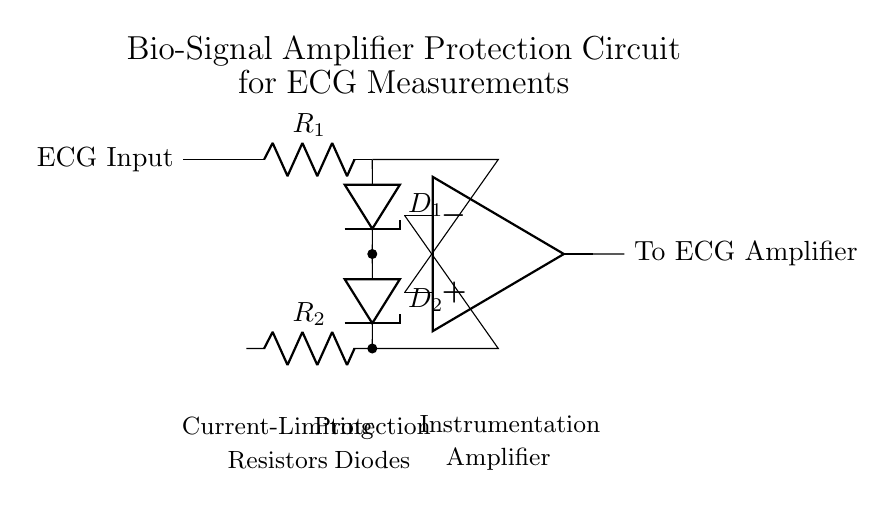What is the purpose of the Zener diodes? The Zener diodes are used for voltage regulation and protection from overvoltage conditions by allowing current to pass in the reverse direction when a specific voltage is exceeded.
Answer: Voltage regulation What are the values of the current-limiting resistors? The circuit diagram identifies the resistors as R1 and R2, but does not specify their numerical values. Their purpose is to limit the current entering the circuit to protect sensitive components.
Answer: R1 and R2 How many diodes are present in the circuit? There are two Zener diodes, D1 and D2, connected in a configuration that offers protection for the ECG signal input, allowing for controlled current flow.
Answer: Two What type of amplifier is used in this circuit? The circuit utilizes an instrumentation amplifier, which is designed to amplify low-level signals while rejecting noise, making it suitable for bio-signal applications like ECG.
Answer: Instrumentation amplifier Which components are responsible for limiting current in this circuit? The current-limiting resistors R1 and R2 in the circuit are responsible for limiting the current, thereby providing necessary protection for the subsequent components including the amplification stage.
Answer: R1 and R2 What is the main function of this circuit? The main function of this bio-signal amplifier protection circuit is to safely amplify ECG signals while protecting the input and amplifier from overvoltage and excessive current conditions.
Answer: Safe amplification 